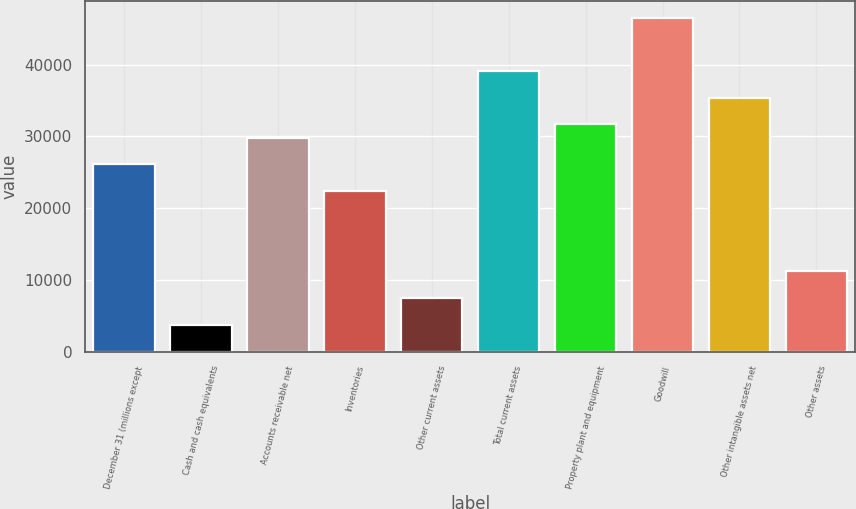Convert chart to OTSL. <chart><loc_0><loc_0><loc_500><loc_500><bar_chart><fcel>December 31 (millions except<fcel>Cash and cash equivalents<fcel>Accounts receivable net<fcel>Inventories<fcel>Other current assets<fcel>Total current assets<fcel>Property plant and equipment<fcel>Goodwill<fcel>Other intangible assets net<fcel>Other assets<nl><fcel>26077.5<fcel>3770.1<fcel>29795.4<fcel>22359.6<fcel>7488<fcel>39090.2<fcel>31654.3<fcel>46525.9<fcel>35372.2<fcel>11205.9<nl></chart> 